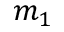<formula> <loc_0><loc_0><loc_500><loc_500>m _ { 1 }</formula> 